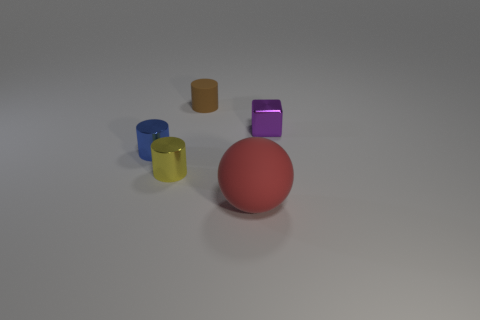Subtract all small brown cylinders. How many cylinders are left? 2 Subtract all blue cylinders. How many cylinders are left? 2 Add 3 yellow cylinders. How many objects exist? 8 Subtract 2 cylinders. How many cylinders are left? 1 Subtract all spheres. How many objects are left? 4 Subtract all cyan cylinders. Subtract all yellow balls. How many cylinders are left? 3 Subtract all red cubes. How many blue spheres are left? 0 Subtract all red spheres. Subtract all tiny purple blocks. How many objects are left? 3 Add 4 rubber things. How many rubber things are left? 6 Add 1 tiny purple rubber cubes. How many tiny purple rubber cubes exist? 1 